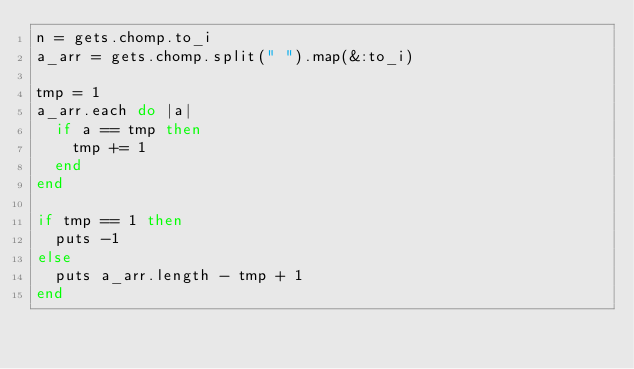Convert code to text. <code><loc_0><loc_0><loc_500><loc_500><_Ruby_>n = gets.chomp.to_i
a_arr = gets.chomp.split(" ").map(&:to_i)

tmp = 1
a_arr.each do |a|
  if a == tmp then
    tmp += 1
  end
end

if tmp == 1 then
  puts -1
else
  puts a_arr.length - tmp + 1
end
</code> 